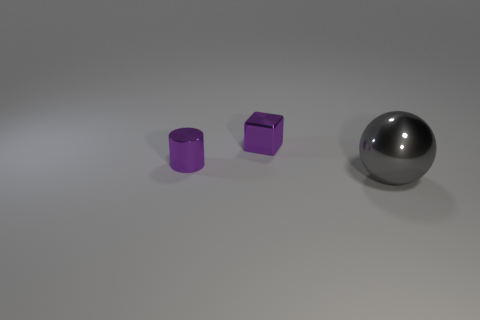Add 3 large purple matte things. How many objects exist? 6 Subtract all cubes. How many objects are left? 2 Subtract all purple cubes. Subtract all metal spheres. How many objects are left? 1 Add 1 gray metal things. How many gray metal things are left? 2 Add 1 small metal things. How many small metal things exist? 3 Subtract 1 gray balls. How many objects are left? 2 